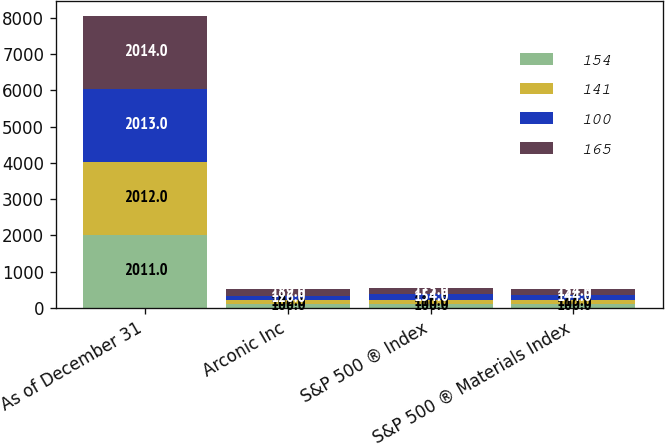Convert chart. <chart><loc_0><loc_0><loc_500><loc_500><stacked_bar_chart><ecel><fcel>As of December 31<fcel>Arconic Inc<fcel>S&P 500 ® Index<fcel>S&P 500 ® Materials Index<nl><fcel>154<fcel>2011<fcel>100<fcel>100<fcel>100<nl><fcel>141<fcel>2012<fcel>102<fcel>116<fcel>115<nl><fcel>100<fcel>2013<fcel>126<fcel>154<fcel>144<nl><fcel>165<fcel>2014<fcel>189<fcel>175<fcel>154<nl></chart> 